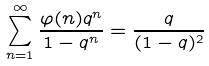<formula> <loc_0><loc_0><loc_500><loc_500>\sum _ { n = 1 } ^ { \infty } { \frac { \varphi ( n ) q ^ { n } } { 1 - q ^ { n } } } = { \frac { q } { ( 1 - q ) ^ { 2 } } }</formula> 